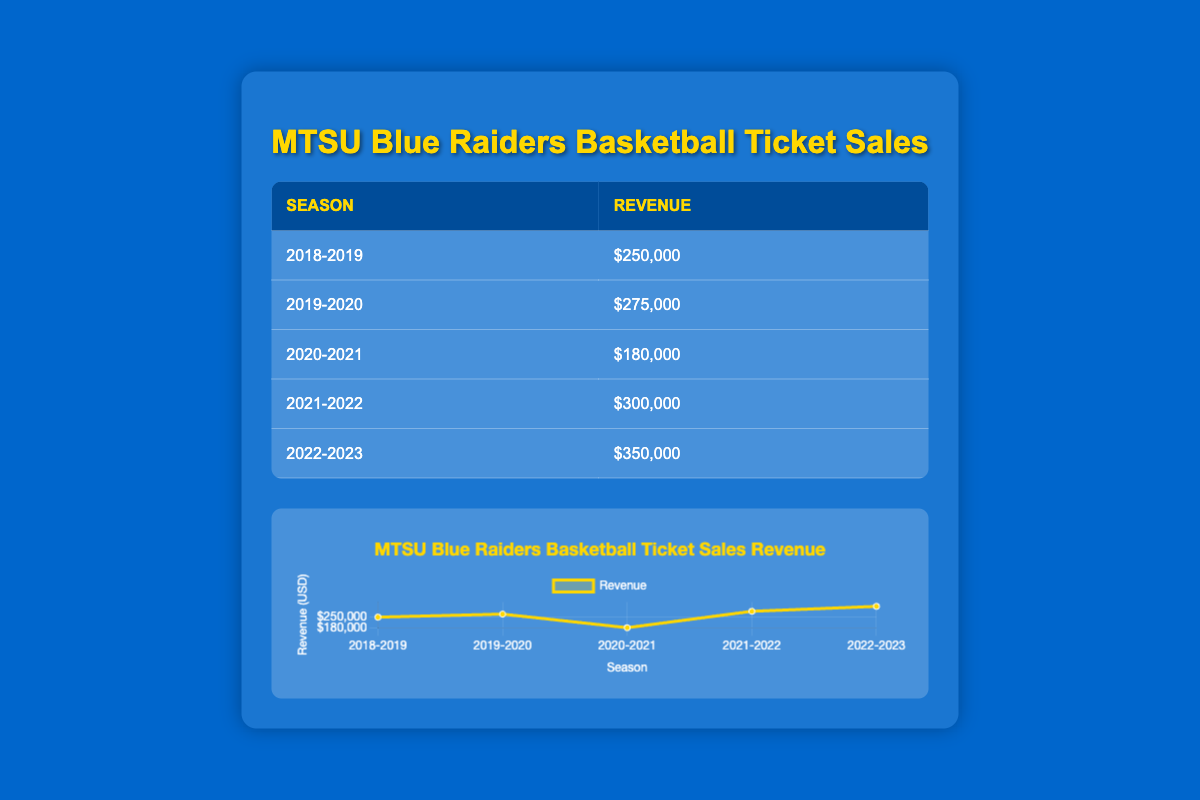What was the revenue for the 2020-2021 season? The table shows the revenue for the 2020-2021 season is $180,000.
Answer: $180,000 What was the revenue in the 2022-2023 season compared to the previous season? For the 2022-2023 season, the revenue was $350,000. In the previous season, 2021-2022, it was $300,000. The difference is $350,000 - $300,000 = $50,000.
Answer: $50,000 Was the revenue higher in the 2019-2020 season than in the 2018-2019 season? The revenue for the 2019-2020 season is $275,000, while the revenue for the 2018-2019 season is $250,000. Since $275,000 is greater than $250,000, the statement is true.
Answer: Yes What was the average revenue of all the listed seasons? To find the average, sum the revenues: $250,000 + $275,000 + $180,000 + $300,000 + $350,000 = $1,355,000. Then divide by the number of seasons (5): $1,355,000 / 5 = $271,000.
Answer: $271,000 Which season generated the highest revenue and what was that revenue? The highest revenue is in the 2022-2023 season, with a revenue of $350,000.
Answer: 2022-2023, $350,000 Is it true that the revenue for the 2021-2022 season was more than $275,000? The revenue for the 2021-2022 season is $300,000, which is indeed greater than $275,000. Therefore, the statement is true.
Answer: Yes What is the change in revenue from the 2020-2021 season to the 2021-2022 season? The revenue for the 2020-2021 season is $180,000 and for the 2021-2022 season is $300,000. The change is $300,000 - $180,000 = $120,000.
Answer: $120,000 Which two seasons had revenues that totaled more than $600,000? The 2021-2022 season had $300,000 and the 2022-2023 season had $350,000. Their total is $300,000 + $350,000 = $650,000, which is more than $600,000.
Answer: 2021-2022 and 2022-2023 What is the percentage increase in revenue from the 2019-2020 season to the 2021-2022 season? The revenue for the 2019-2020 season was $275,000 and for the 2021-2022 season it was $300,000. The increase is $300,000 - $275,000 = $25,000. To find the percentage increase: ($25,000 / $275,000) * 100 ≈ 9.09%.
Answer: Approximately 9.09% 